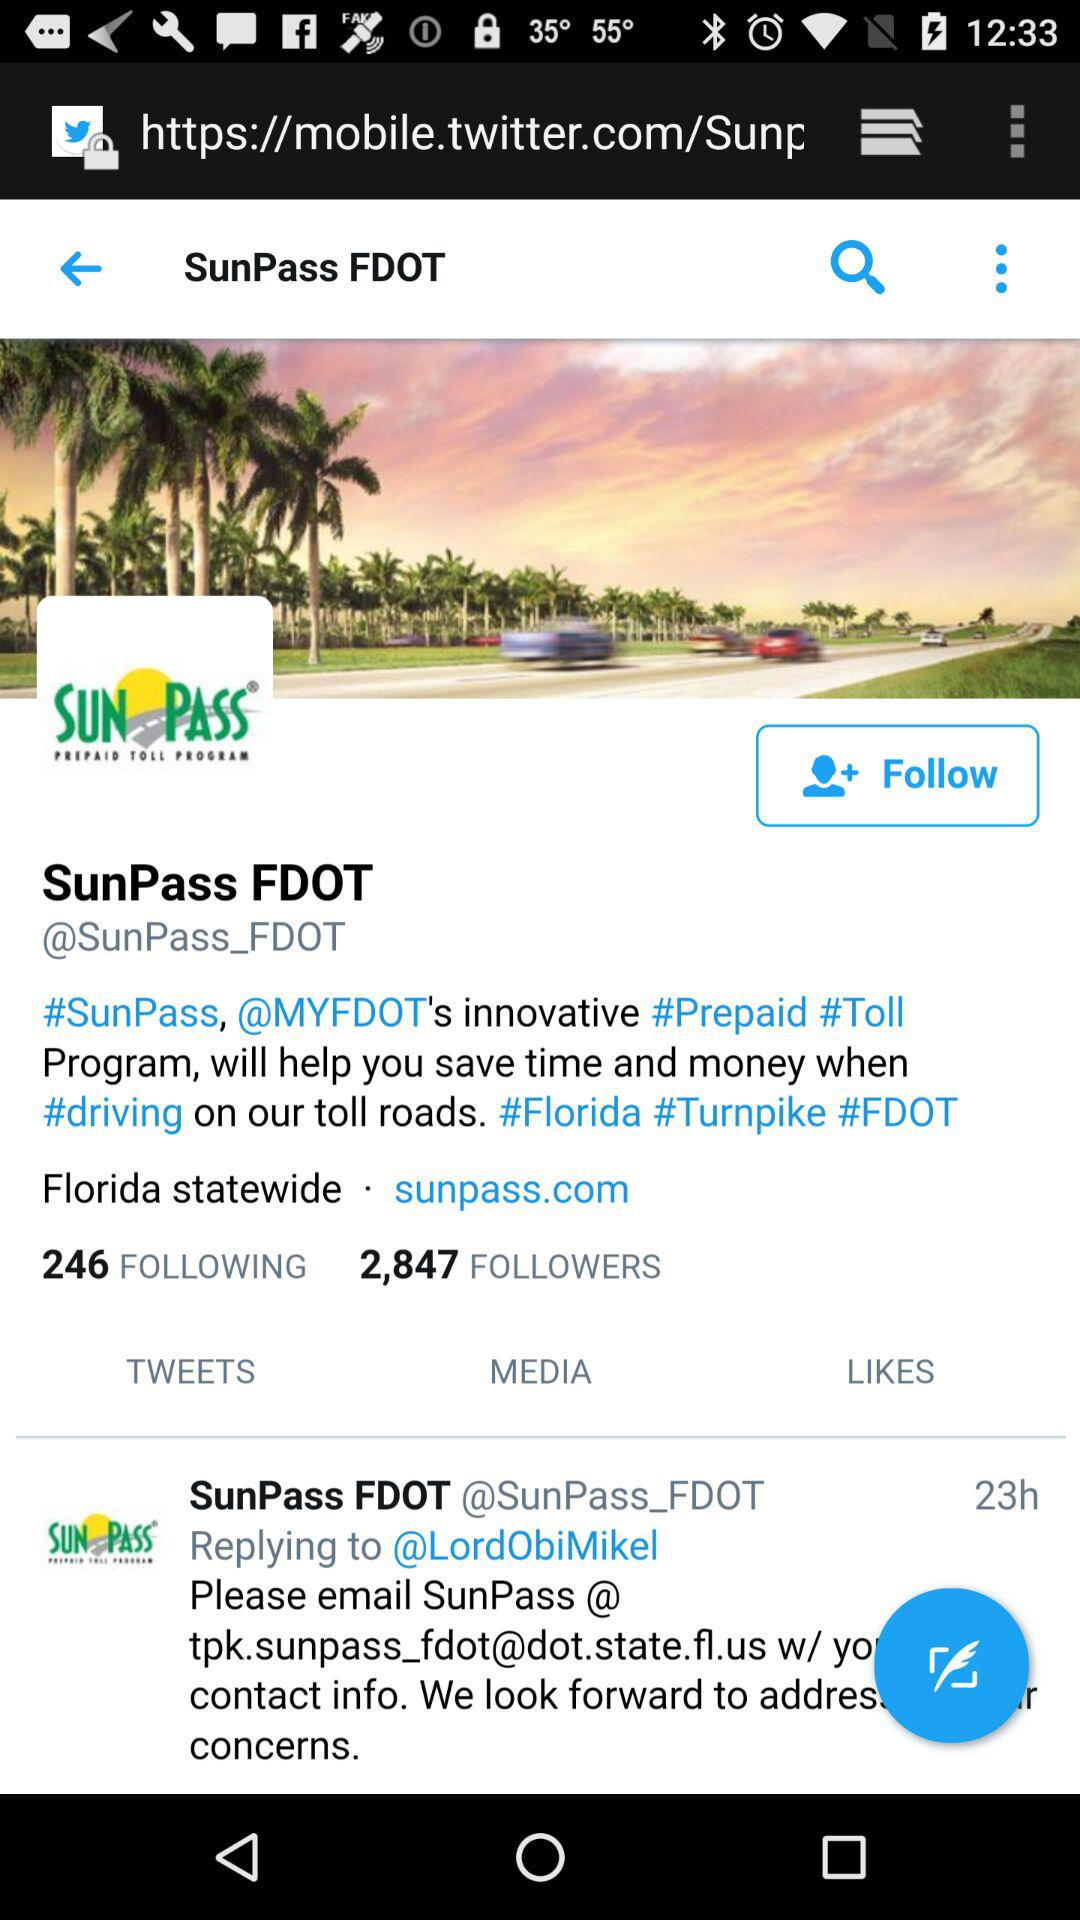When did "SunPass FDOT" reply to "@LordObiMikel"? "SunPass FDOT" replied to "@LordObiMikel" 23 hours ago. 